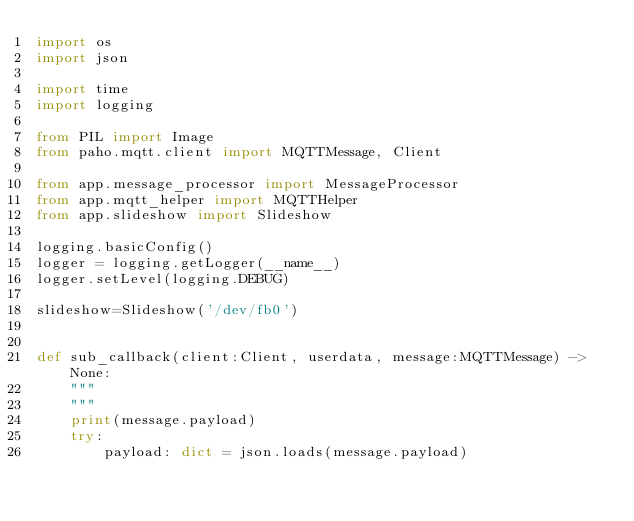<code> <loc_0><loc_0><loc_500><loc_500><_Python_>import os
import json

import time
import logging

from PIL import Image
from paho.mqtt.client import MQTTMessage, Client

from app.message_processor import MessageProcessor
from app.mqtt_helper import MQTTHelper
from app.slideshow import Slideshow

logging.basicConfig()
logger = logging.getLogger(__name__)
logger.setLevel(logging.DEBUG)

slideshow=Slideshow('/dev/fb0')


def sub_callback(client:Client, userdata, message:MQTTMessage) -> None:
    """
    """
    print(message.payload)
    try:
        payload: dict = json.loads(message.payload)</code> 